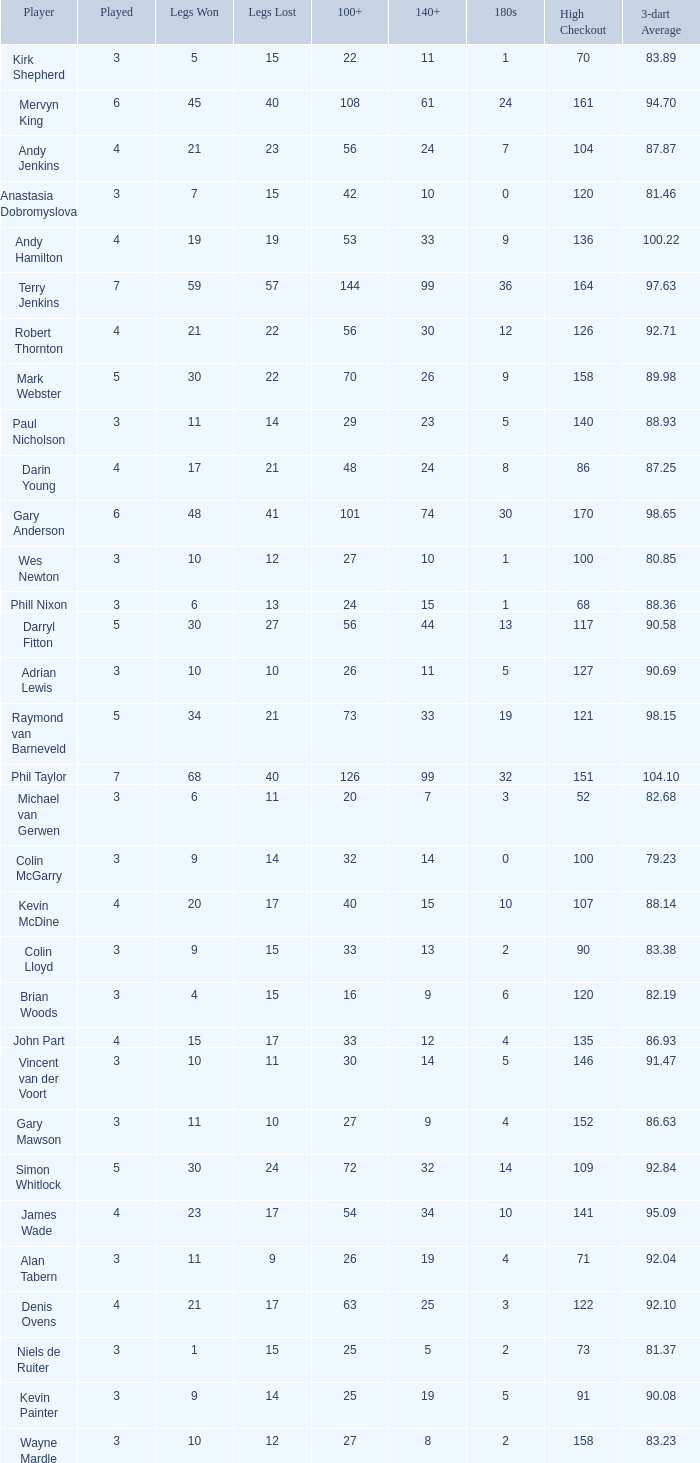What is the highest Legs Lost with a 180s larger than 1, a 100+ of 53, and played is smaller than 4? None. 